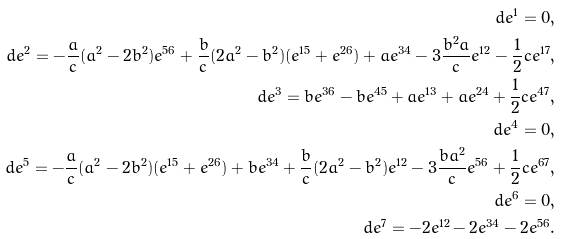<formula> <loc_0><loc_0><loc_500><loc_500>d e ^ { 1 } = 0 , \\ d e ^ { 2 } = - \frac { a } { c } ( a ^ { 2 } - 2 b ^ { 2 } ) e ^ { 5 6 } + \frac { b } { c } ( 2 a ^ { 2 } - b ^ { 2 } ) ( e ^ { 1 5 } + e ^ { 2 6 } ) + a e ^ { 3 4 } - 3 \frac { b ^ { 2 } a } { c } e ^ { 1 2 } - \frac { 1 } { 2 } { c } e ^ { 1 7 } , \\ d e ^ { 3 } = b e ^ { 3 6 } - b e ^ { 4 5 } + a e ^ { 1 3 } + a e ^ { 2 4 } + \frac { 1 } { 2 } { c } e ^ { 4 7 } , \\ d e ^ { 4 } = 0 , \\ d e ^ { 5 } = - \frac { a } { c } ( a ^ { 2 } - 2 b ^ { 2 } ) ( e ^ { 1 5 } + e ^ { 2 6 } ) + b e ^ { 3 4 } + \frac { b } { c } ( 2 a ^ { 2 } - b ^ { 2 } ) e ^ { 1 2 } - 3 \frac { b a ^ { 2 } } { c } e ^ { 5 6 } + \frac { 1 } { 2 } { c } e ^ { 6 7 } , \\ d e ^ { 6 } = 0 , \\ d e ^ { 7 } = - 2 e ^ { 1 2 } - 2 e ^ { 3 4 } - 2 e ^ { 5 6 } .</formula> 